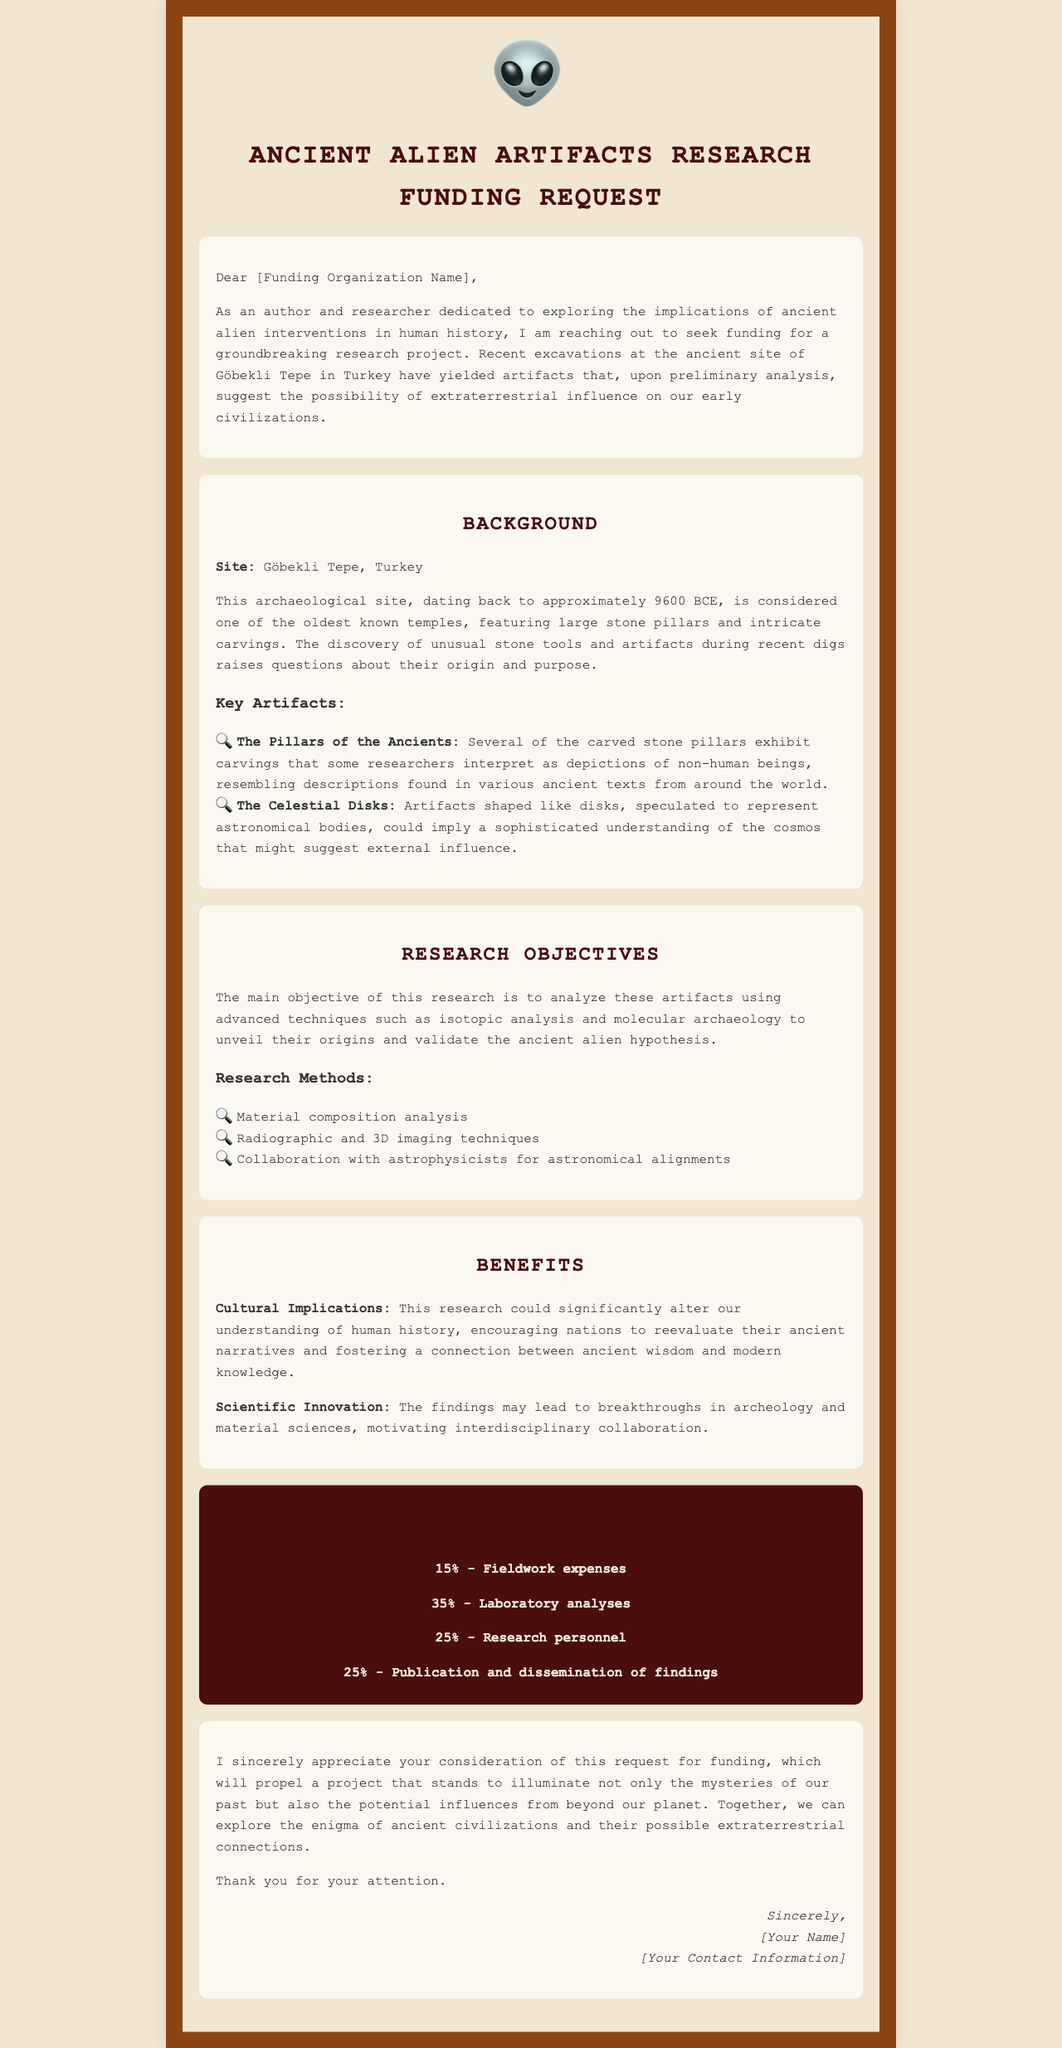What is the name of the archaeological site mentioned? The archaeological site referenced is Göbekli Tepe, which is specified in the background section.
Answer: Göbekli Tepe What year does Göbekli Tepe date back to? The document states that Göbekli Tepe dates back to approximately 9600 BCE.
Answer: 9600 BCE What is the requested amount of funding for the research project? The funding request section clearly states the amount requested for the research project is $150,000.
Answer: $150,000 What percentage of the funding is allocated for laboratory analyses? The funding breakdown indicates that 35% is designated for laboratory analyses.
Answer: 35% What are the two key artifacts mentioned in the document? The artifacts listed are The Pillars of the Ancients and The Celestial Disks.
Answer: The Pillars of the Ancients, The Celestial Disks What is a primary objective of the research? The main objective noted in the document is to analyze the artifacts to unveil their origins and validate the ancient alien hypothesis.
Answer: Analyze artifacts What type of imaging techniques are mentioned as part of the research methods? The research methods include radiographic and 3D imaging techniques as specified in the document.
Answer: Radiographic and 3D imaging techniques What impact could this research have on cultural understanding? The document states this research could significantly alter our understanding of human history and encourage nations to reevaluate their ancient narratives.
Answer: Alter understanding of human history What is the signature style noted at the end of the document? The document features an italicized signature style at the end.
Answer: Italicized 